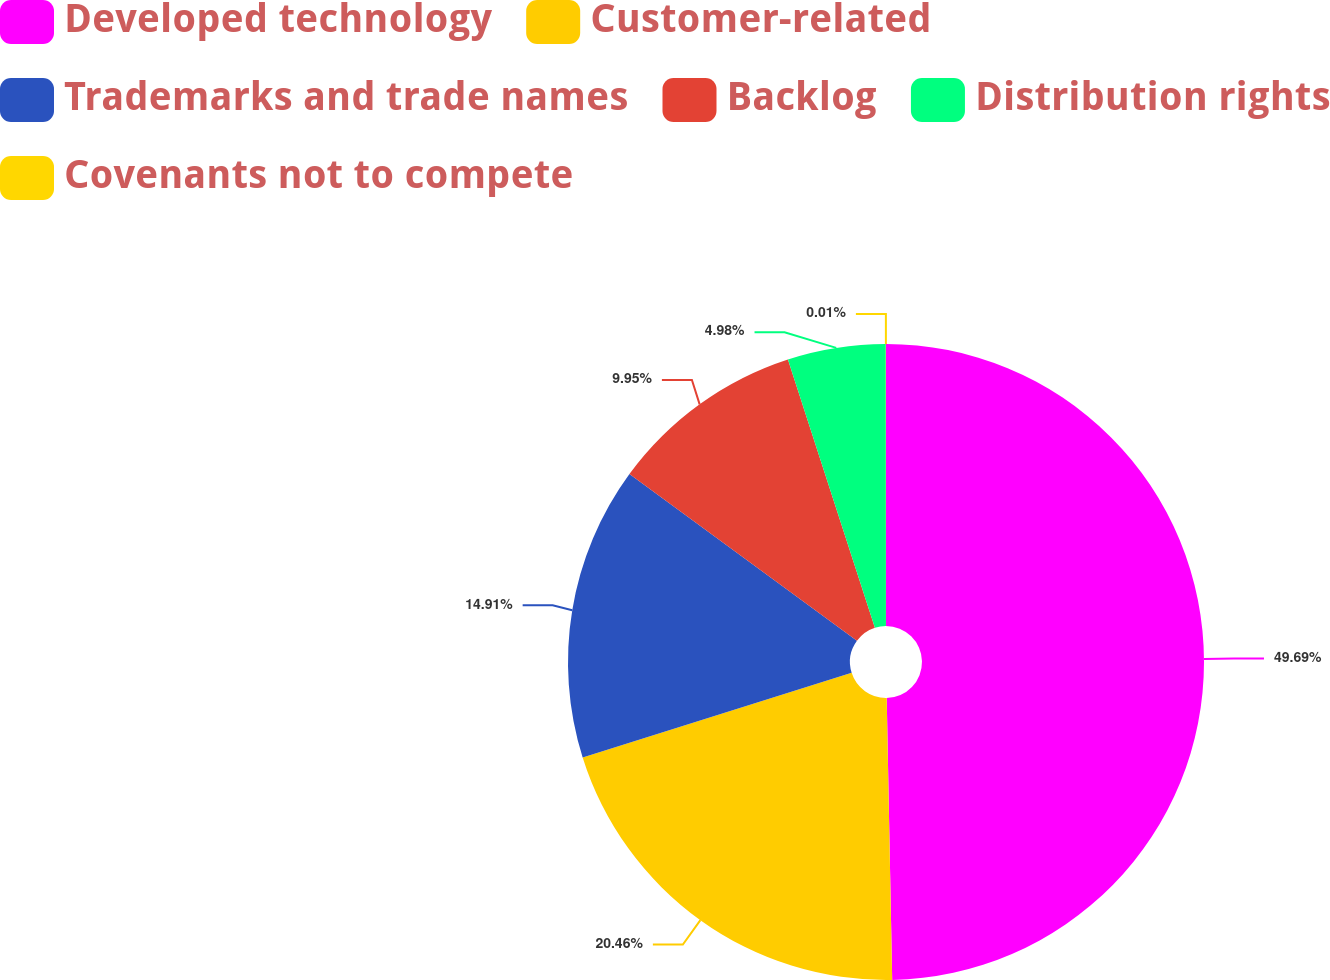Convert chart. <chart><loc_0><loc_0><loc_500><loc_500><pie_chart><fcel>Developed technology<fcel>Customer-related<fcel>Trademarks and trade names<fcel>Backlog<fcel>Distribution rights<fcel>Covenants not to compete<nl><fcel>49.69%<fcel>20.46%<fcel>14.91%<fcel>9.95%<fcel>4.98%<fcel>0.01%<nl></chart> 